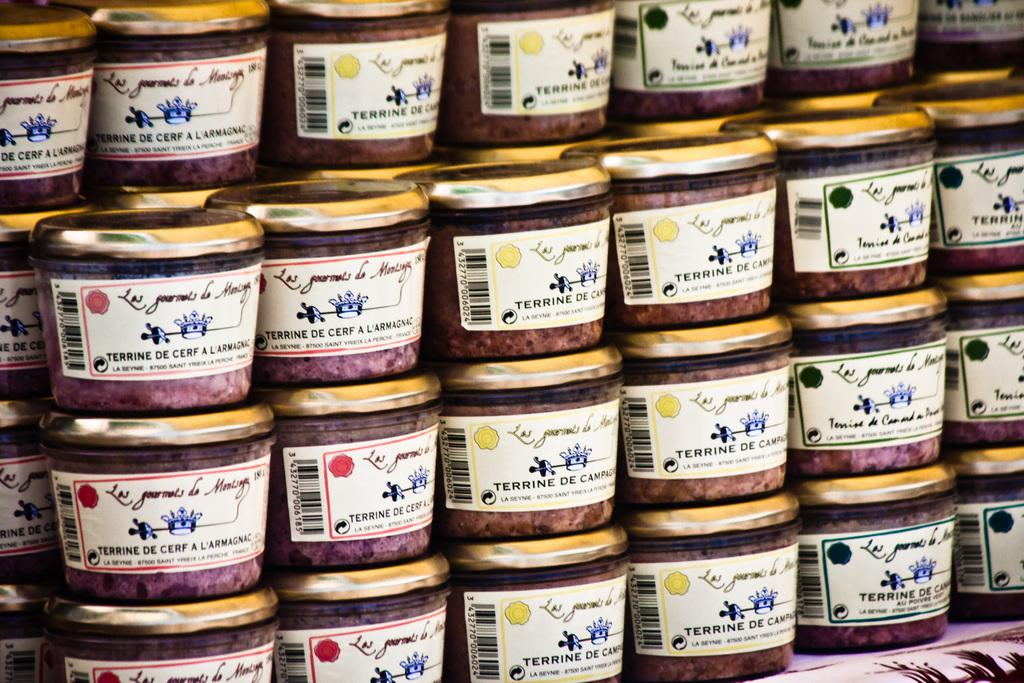<image>
Present a compact description of the photo's key features. Jars of Terrine De Campagns stacked on top of each other. 